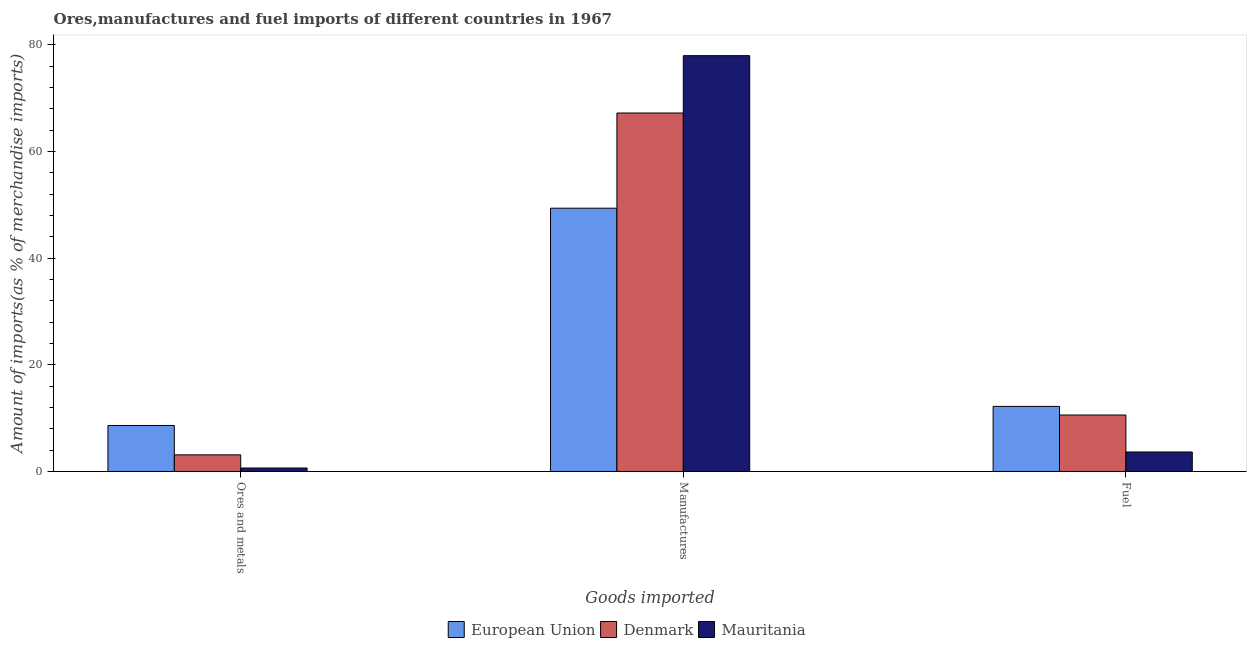How many different coloured bars are there?
Make the answer very short. 3. How many bars are there on the 3rd tick from the left?
Provide a short and direct response. 3. How many bars are there on the 1st tick from the right?
Keep it short and to the point. 3. What is the label of the 2nd group of bars from the left?
Your response must be concise. Manufactures. What is the percentage of manufactures imports in European Union?
Offer a terse response. 49.35. Across all countries, what is the maximum percentage of manufactures imports?
Give a very brief answer. 77.94. Across all countries, what is the minimum percentage of manufactures imports?
Offer a terse response. 49.35. In which country was the percentage of manufactures imports maximum?
Provide a succinct answer. Mauritania. In which country was the percentage of ores and metals imports minimum?
Make the answer very short. Mauritania. What is the total percentage of manufactures imports in the graph?
Provide a succinct answer. 194.49. What is the difference between the percentage of ores and metals imports in European Union and that in Denmark?
Keep it short and to the point. 5.5. What is the difference between the percentage of manufactures imports in Denmark and the percentage of fuel imports in European Union?
Provide a succinct answer. 54.99. What is the average percentage of fuel imports per country?
Keep it short and to the point. 8.81. What is the difference between the percentage of manufactures imports and percentage of fuel imports in Mauritania?
Make the answer very short. 74.29. In how many countries, is the percentage of manufactures imports greater than 20 %?
Make the answer very short. 3. What is the ratio of the percentage of ores and metals imports in Mauritania to that in Denmark?
Give a very brief answer. 0.21. What is the difference between the highest and the second highest percentage of ores and metals imports?
Make the answer very short. 5.5. What is the difference between the highest and the lowest percentage of fuel imports?
Your response must be concise. 8.55. What does the 2nd bar from the left in Ores and metals represents?
Offer a terse response. Denmark. What does the 3rd bar from the right in Fuel represents?
Your answer should be very brief. European Union. Is it the case that in every country, the sum of the percentage of ores and metals imports and percentage of manufactures imports is greater than the percentage of fuel imports?
Ensure brevity in your answer.  Yes. How many countries are there in the graph?
Give a very brief answer. 3. What is the difference between two consecutive major ticks on the Y-axis?
Your answer should be very brief. 20. Does the graph contain grids?
Offer a very short reply. No. Where does the legend appear in the graph?
Offer a terse response. Bottom center. What is the title of the graph?
Provide a short and direct response. Ores,manufactures and fuel imports of different countries in 1967. What is the label or title of the X-axis?
Provide a succinct answer. Goods imported. What is the label or title of the Y-axis?
Your response must be concise. Amount of imports(as % of merchandise imports). What is the Amount of imports(as % of merchandise imports) in European Union in Ores and metals?
Provide a succinct answer. 8.62. What is the Amount of imports(as % of merchandise imports) in Denmark in Ores and metals?
Give a very brief answer. 3.12. What is the Amount of imports(as % of merchandise imports) in Mauritania in Ores and metals?
Provide a short and direct response. 0.65. What is the Amount of imports(as % of merchandise imports) of European Union in Manufactures?
Provide a succinct answer. 49.35. What is the Amount of imports(as % of merchandise imports) of Denmark in Manufactures?
Make the answer very short. 67.19. What is the Amount of imports(as % of merchandise imports) in Mauritania in Manufactures?
Keep it short and to the point. 77.94. What is the Amount of imports(as % of merchandise imports) in European Union in Fuel?
Make the answer very short. 12.2. What is the Amount of imports(as % of merchandise imports) in Denmark in Fuel?
Offer a terse response. 10.58. What is the Amount of imports(as % of merchandise imports) of Mauritania in Fuel?
Offer a terse response. 3.66. Across all Goods imported, what is the maximum Amount of imports(as % of merchandise imports) in European Union?
Provide a succinct answer. 49.35. Across all Goods imported, what is the maximum Amount of imports(as % of merchandise imports) of Denmark?
Make the answer very short. 67.19. Across all Goods imported, what is the maximum Amount of imports(as % of merchandise imports) in Mauritania?
Your answer should be compact. 77.94. Across all Goods imported, what is the minimum Amount of imports(as % of merchandise imports) of European Union?
Offer a very short reply. 8.62. Across all Goods imported, what is the minimum Amount of imports(as % of merchandise imports) of Denmark?
Your answer should be compact. 3.12. Across all Goods imported, what is the minimum Amount of imports(as % of merchandise imports) of Mauritania?
Your response must be concise. 0.65. What is the total Amount of imports(as % of merchandise imports) in European Union in the graph?
Your response must be concise. 70.17. What is the total Amount of imports(as % of merchandise imports) of Denmark in the graph?
Your answer should be very brief. 80.9. What is the total Amount of imports(as % of merchandise imports) of Mauritania in the graph?
Give a very brief answer. 82.25. What is the difference between the Amount of imports(as % of merchandise imports) in European Union in Ores and metals and that in Manufactures?
Provide a short and direct response. -40.73. What is the difference between the Amount of imports(as % of merchandise imports) of Denmark in Ores and metals and that in Manufactures?
Your answer should be very brief. -64.08. What is the difference between the Amount of imports(as % of merchandise imports) of Mauritania in Ores and metals and that in Manufactures?
Offer a very short reply. -77.29. What is the difference between the Amount of imports(as % of merchandise imports) of European Union in Ores and metals and that in Fuel?
Your answer should be compact. -3.58. What is the difference between the Amount of imports(as % of merchandise imports) of Denmark in Ores and metals and that in Fuel?
Your response must be concise. -7.47. What is the difference between the Amount of imports(as % of merchandise imports) of Mauritania in Ores and metals and that in Fuel?
Provide a short and direct response. -3. What is the difference between the Amount of imports(as % of merchandise imports) of European Union in Manufactures and that in Fuel?
Offer a very short reply. 37.15. What is the difference between the Amount of imports(as % of merchandise imports) of Denmark in Manufactures and that in Fuel?
Provide a succinct answer. 56.61. What is the difference between the Amount of imports(as % of merchandise imports) in Mauritania in Manufactures and that in Fuel?
Offer a very short reply. 74.29. What is the difference between the Amount of imports(as % of merchandise imports) of European Union in Ores and metals and the Amount of imports(as % of merchandise imports) of Denmark in Manufactures?
Your answer should be very brief. -58.57. What is the difference between the Amount of imports(as % of merchandise imports) in European Union in Ores and metals and the Amount of imports(as % of merchandise imports) in Mauritania in Manufactures?
Give a very brief answer. -69.32. What is the difference between the Amount of imports(as % of merchandise imports) in Denmark in Ores and metals and the Amount of imports(as % of merchandise imports) in Mauritania in Manufactures?
Provide a succinct answer. -74.82. What is the difference between the Amount of imports(as % of merchandise imports) of European Union in Ores and metals and the Amount of imports(as % of merchandise imports) of Denmark in Fuel?
Give a very brief answer. -1.96. What is the difference between the Amount of imports(as % of merchandise imports) of European Union in Ores and metals and the Amount of imports(as % of merchandise imports) of Mauritania in Fuel?
Ensure brevity in your answer.  4.97. What is the difference between the Amount of imports(as % of merchandise imports) in Denmark in Ores and metals and the Amount of imports(as % of merchandise imports) in Mauritania in Fuel?
Ensure brevity in your answer.  -0.54. What is the difference between the Amount of imports(as % of merchandise imports) in European Union in Manufactures and the Amount of imports(as % of merchandise imports) in Denmark in Fuel?
Ensure brevity in your answer.  38.77. What is the difference between the Amount of imports(as % of merchandise imports) of European Union in Manufactures and the Amount of imports(as % of merchandise imports) of Mauritania in Fuel?
Provide a succinct answer. 45.7. What is the difference between the Amount of imports(as % of merchandise imports) in Denmark in Manufactures and the Amount of imports(as % of merchandise imports) in Mauritania in Fuel?
Your response must be concise. 63.54. What is the average Amount of imports(as % of merchandise imports) in European Union per Goods imported?
Provide a succinct answer. 23.39. What is the average Amount of imports(as % of merchandise imports) in Denmark per Goods imported?
Make the answer very short. 26.97. What is the average Amount of imports(as % of merchandise imports) in Mauritania per Goods imported?
Offer a terse response. 27.42. What is the difference between the Amount of imports(as % of merchandise imports) of European Union and Amount of imports(as % of merchandise imports) of Denmark in Ores and metals?
Your response must be concise. 5.5. What is the difference between the Amount of imports(as % of merchandise imports) in European Union and Amount of imports(as % of merchandise imports) in Mauritania in Ores and metals?
Provide a succinct answer. 7.97. What is the difference between the Amount of imports(as % of merchandise imports) in Denmark and Amount of imports(as % of merchandise imports) in Mauritania in Ores and metals?
Your answer should be very brief. 2.47. What is the difference between the Amount of imports(as % of merchandise imports) of European Union and Amount of imports(as % of merchandise imports) of Denmark in Manufactures?
Make the answer very short. -17.84. What is the difference between the Amount of imports(as % of merchandise imports) in European Union and Amount of imports(as % of merchandise imports) in Mauritania in Manufactures?
Your answer should be compact. -28.59. What is the difference between the Amount of imports(as % of merchandise imports) in Denmark and Amount of imports(as % of merchandise imports) in Mauritania in Manufactures?
Ensure brevity in your answer.  -10.75. What is the difference between the Amount of imports(as % of merchandise imports) of European Union and Amount of imports(as % of merchandise imports) of Denmark in Fuel?
Your answer should be compact. 1.62. What is the difference between the Amount of imports(as % of merchandise imports) in European Union and Amount of imports(as % of merchandise imports) in Mauritania in Fuel?
Your answer should be compact. 8.55. What is the difference between the Amount of imports(as % of merchandise imports) of Denmark and Amount of imports(as % of merchandise imports) of Mauritania in Fuel?
Offer a terse response. 6.93. What is the ratio of the Amount of imports(as % of merchandise imports) of European Union in Ores and metals to that in Manufactures?
Your response must be concise. 0.17. What is the ratio of the Amount of imports(as % of merchandise imports) in Denmark in Ores and metals to that in Manufactures?
Offer a very short reply. 0.05. What is the ratio of the Amount of imports(as % of merchandise imports) in Mauritania in Ores and metals to that in Manufactures?
Provide a succinct answer. 0.01. What is the ratio of the Amount of imports(as % of merchandise imports) in European Union in Ores and metals to that in Fuel?
Ensure brevity in your answer.  0.71. What is the ratio of the Amount of imports(as % of merchandise imports) of Denmark in Ores and metals to that in Fuel?
Offer a very short reply. 0.29. What is the ratio of the Amount of imports(as % of merchandise imports) of Mauritania in Ores and metals to that in Fuel?
Offer a very short reply. 0.18. What is the ratio of the Amount of imports(as % of merchandise imports) in European Union in Manufactures to that in Fuel?
Keep it short and to the point. 4.04. What is the ratio of the Amount of imports(as % of merchandise imports) in Denmark in Manufactures to that in Fuel?
Provide a short and direct response. 6.35. What is the ratio of the Amount of imports(as % of merchandise imports) of Mauritania in Manufactures to that in Fuel?
Ensure brevity in your answer.  21.32. What is the difference between the highest and the second highest Amount of imports(as % of merchandise imports) in European Union?
Make the answer very short. 37.15. What is the difference between the highest and the second highest Amount of imports(as % of merchandise imports) of Denmark?
Provide a succinct answer. 56.61. What is the difference between the highest and the second highest Amount of imports(as % of merchandise imports) in Mauritania?
Offer a very short reply. 74.29. What is the difference between the highest and the lowest Amount of imports(as % of merchandise imports) in European Union?
Provide a succinct answer. 40.73. What is the difference between the highest and the lowest Amount of imports(as % of merchandise imports) in Denmark?
Offer a very short reply. 64.08. What is the difference between the highest and the lowest Amount of imports(as % of merchandise imports) in Mauritania?
Offer a very short reply. 77.29. 